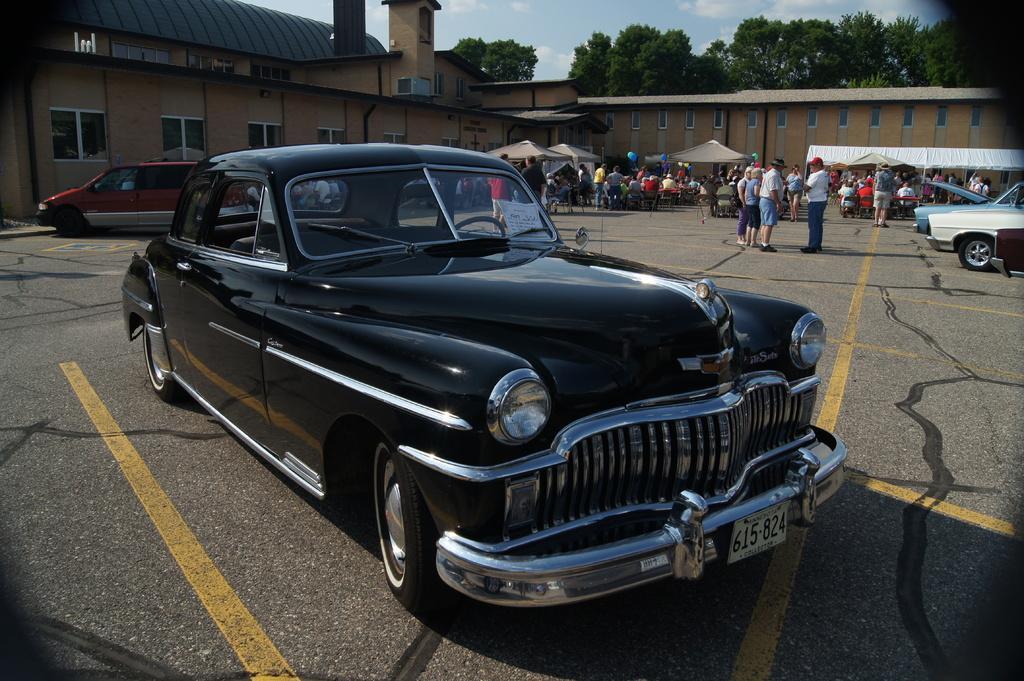Please provide a concise description of this image. In this image, in the foreground there is a black color car background is the sky. 